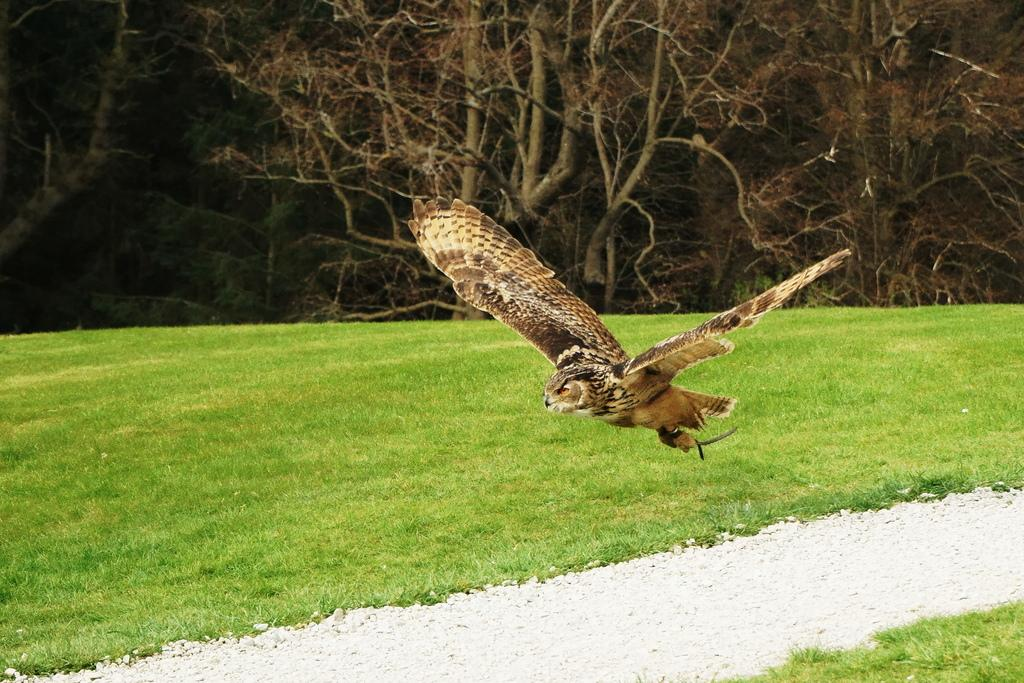What animal is the main subject of the image? There is an eagle in the image. What is the eagle doing in the image? The eagle is flying. What type of environment can be seen in the background of the image? There is grass and trees visible in the background of the image. What type of ear is visible on the eagle in the image? Eagles do not have visible external ears like humans; their ears are covered by feathers. --- 